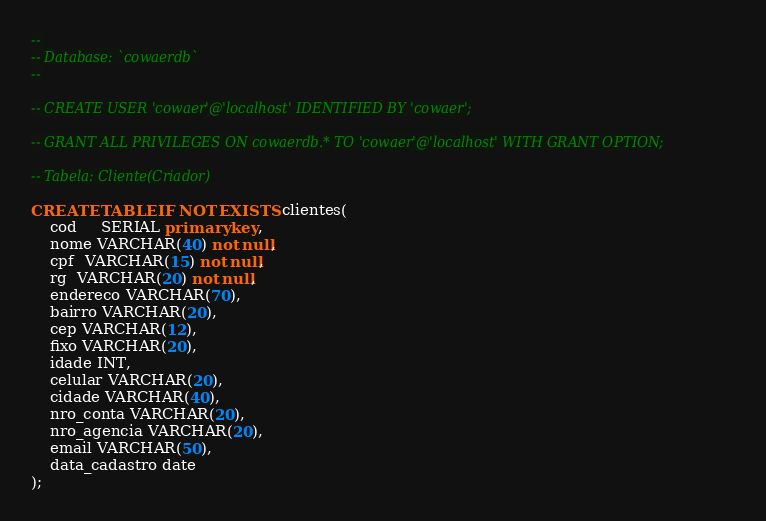<code> <loc_0><loc_0><loc_500><loc_500><_SQL_>--
-- Database: `cowaerdb`
--

-- CREATE USER 'cowaer'@'localhost' IDENTIFIED BY 'cowaer';

-- GRANT ALL PRIVILEGES ON cowaerdb.* TO 'cowaer'@'localhost' WITH GRANT OPTION;

-- Tabela: Cliente(Criador)

CREATE TABLE IF NOT EXISTS clientes(
	cod	 SERIAL primary key,
	nome VARCHAR(40) not null,
	cpf  VARCHAR(15) not null,
	rg  VARCHAR(20) not null,
	endereco VARCHAR(70),
	bairro VARCHAR(20),
	cep VARCHAR(12),
	fixo VARCHAR(20),
	idade INT,
	celular VARCHAR(20),
	cidade VARCHAR(40),
	nro_conta VARCHAR(20),
	nro_agencia VARCHAR(20),
	email VARCHAR(50),
	data_cadastro date
);
</code> 